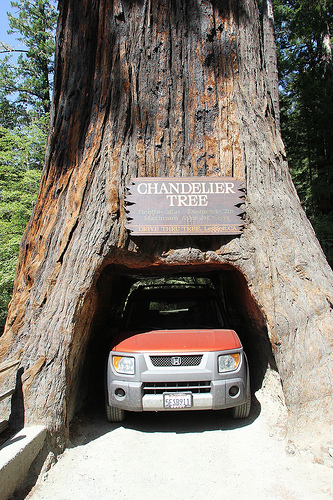<image>
Can you confirm if the truck is to the right of the tree? No. The truck is not to the right of the tree. The horizontal positioning shows a different relationship. Is the tunnel in the tree? Yes. The tunnel is contained within or inside the tree, showing a containment relationship. 